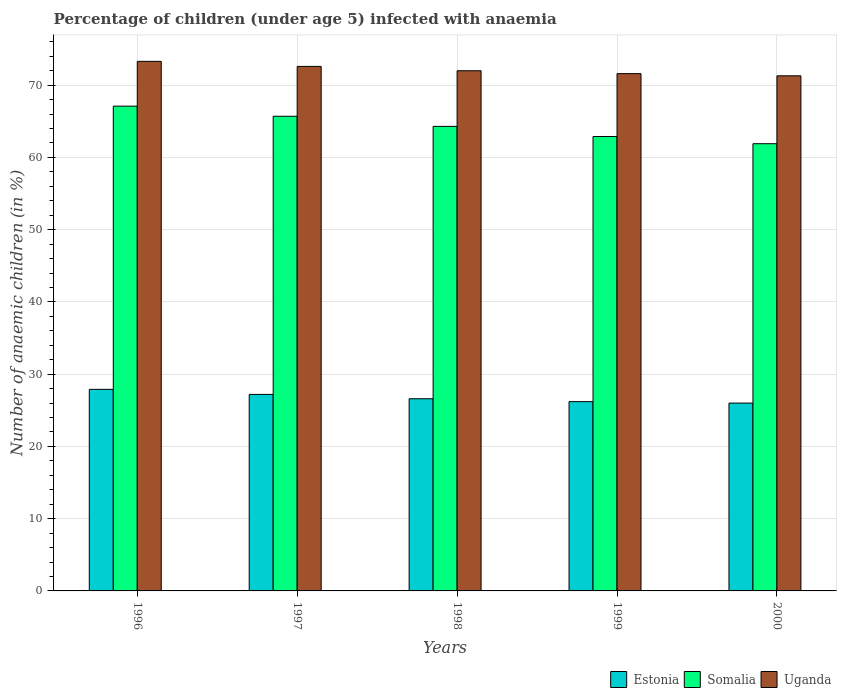How many different coloured bars are there?
Provide a short and direct response. 3. How many groups of bars are there?
Provide a short and direct response. 5. In how many cases, is the number of bars for a given year not equal to the number of legend labels?
Provide a succinct answer. 0. What is the percentage of children infected with anaemia in in Uganda in 1997?
Provide a succinct answer. 72.6. Across all years, what is the maximum percentage of children infected with anaemia in in Estonia?
Your answer should be compact. 27.9. Across all years, what is the minimum percentage of children infected with anaemia in in Uganda?
Provide a short and direct response. 71.3. What is the total percentage of children infected with anaemia in in Uganda in the graph?
Keep it short and to the point. 360.8. What is the difference between the percentage of children infected with anaemia in in Uganda in 1998 and that in 2000?
Give a very brief answer. 0.7. What is the average percentage of children infected with anaemia in in Estonia per year?
Provide a short and direct response. 26.78. In the year 1996, what is the difference between the percentage of children infected with anaemia in in Uganda and percentage of children infected with anaemia in in Estonia?
Keep it short and to the point. 45.4. In how many years, is the percentage of children infected with anaemia in in Estonia greater than 10 %?
Offer a terse response. 5. What is the ratio of the percentage of children infected with anaemia in in Estonia in 1996 to that in 1997?
Ensure brevity in your answer.  1.03. Is the percentage of children infected with anaemia in in Somalia in 1996 less than that in 1997?
Your response must be concise. No. Is the difference between the percentage of children infected with anaemia in in Uganda in 1998 and 2000 greater than the difference between the percentage of children infected with anaemia in in Estonia in 1998 and 2000?
Ensure brevity in your answer.  Yes. What is the difference between the highest and the second highest percentage of children infected with anaemia in in Estonia?
Ensure brevity in your answer.  0.7. What is the difference between the highest and the lowest percentage of children infected with anaemia in in Somalia?
Your answer should be very brief. 5.2. In how many years, is the percentage of children infected with anaemia in in Somalia greater than the average percentage of children infected with anaemia in in Somalia taken over all years?
Offer a very short reply. 2. Is the sum of the percentage of children infected with anaemia in in Estonia in 1998 and 2000 greater than the maximum percentage of children infected with anaemia in in Somalia across all years?
Provide a succinct answer. No. What does the 2nd bar from the left in 1997 represents?
Offer a very short reply. Somalia. What does the 3rd bar from the right in 1997 represents?
Ensure brevity in your answer.  Estonia. How many years are there in the graph?
Your response must be concise. 5. Does the graph contain any zero values?
Make the answer very short. No. How many legend labels are there?
Keep it short and to the point. 3. What is the title of the graph?
Provide a short and direct response. Percentage of children (under age 5) infected with anaemia. Does "World" appear as one of the legend labels in the graph?
Make the answer very short. No. What is the label or title of the Y-axis?
Your answer should be very brief. Number of anaemic children (in %). What is the Number of anaemic children (in %) of Estonia in 1996?
Keep it short and to the point. 27.9. What is the Number of anaemic children (in %) of Somalia in 1996?
Your response must be concise. 67.1. What is the Number of anaemic children (in %) in Uganda in 1996?
Make the answer very short. 73.3. What is the Number of anaemic children (in %) of Estonia in 1997?
Your response must be concise. 27.2. What is the Number of anaemic children (in %) in Somalia in 1997?
Your response must be concise. 65.7. What is the Number of anaemic children (in %) of Uganda in 1997?
Make the answer very short. 72.6. What is the Number of anaemic children (in %) in Estonia in 1998?
Your response must be concise. 26.6. What is the Number of anaemic children (in %) of Somalia in 1998?
Keep it short and to the point. 64.3. What is the Number of anaemic children (in %) in Uganda in 1998?
Keep it short and to the point. 72. What is the Number of anaemic children (in %) of Estonia in 1999?
Provide a short and direct response. 26.2. What is the Number of anaemic children (in %) in Somalia in 1999?
Make the answer very short. 62.9. What is the Number of anaemic children (in %) of Uganda in 1999?
Your answer should be very brief. 71.6. What is the Number of anaemic children (in %) of Estonia in 2000?
Your response must be concise. 26. What is the Number of anaemic children (in %) of Somalia in 2000?
Make the answer very short. 61.9. What is the Number of anaemic children (in %) in Uganda in 2000?
Make the answer very short. 71.3. Across all years, what is the maximum Number of anaemic children (in %) of Estonia?
Your response must be concise. 27.9. Across all years, what is the maximum Number of anaemic children (in %) in Somalia?
Provide a short and direct response. 67.1. Across all years, what is the maximum Number of anaemic children (in %) of Uganda?
Offer a terse response. 73.3. Across all years, what is the minimum Number of anaemic children (in %) of Estonia?
Keep it short and to the point. 26. Across all years, what is the minimum Number of anaemic children (in %) of Somalia?
Your answer should be compact. 61.9. Across all years, what is the minimum Number of anaemic children (in %) in Uganda?
Provide a short and direct response. 71.3. What is the total Number of anaemic children (in %) in Estonia in the graph?
Your answer should be compact. 133.9. What is the total Number of anaemic children (in %) in Somalia in the graph?
Your answer should be very brief. 321.9. What is the total Number of anaemic children (in %) in Uganda in the graph?
Your answer should be very brief. 360.8. What is the difference between the Number of anaemic children (in %) of Uganda in 1996 and that in 1998?
Offer a very short reply. 1.3. What is the difference between the Number of anaemic children (in %) in Estonia in 1996 and that in 2000?
Offer a terse response. 1.9. What is the difference between the Number of anaemic children (in %) in Uganda in 1996 and that in 2000?
Provide a short and direct response. 2. What is the difference between the Number of anaemic children (in %) in Somalia in 1997 and that in 1998?
Keep it short and to the point. 1.4. What is the difference between the Number of anaemic children (in %) of Uganda in 1997 and that in 1998?
Offer a very short reply. 0.6. What is the difference between the Number of anaemic children (in %) of Estonia in 1997 and that in 1999?
Provide a succinct answer. 1. What is the difference between the Number of anaemic children (in %) of Somalia in 1997 and that in 1999?
Your answer should be compact. 2.8. What is the difference between the Number of anaemic children (in %) in Uganda in 1997 and that in 1999?
Provide a short and direct response. 1. What is the difference between the Number of anaemic children (in %) of Estonia in 1997 and that in 2000?
Provide a short and direct response. 1.2. What is the difference between the Number of anaemic children (in %) in Estonia in 1998 and that in 2000?
Offer a terse response. 0.6. What is the difference between the Number of anaemic children (in %) in Uganda in 1998 and that in 2000?
Offer a terse response. 0.7. What is the difference between the Number of anaemic children (in %) in Uganda in 1999 and that in 2000?
Make the answer very short. 0.3. What is the difference between the Number of anaemic children (in %) in Estonia in 1996 and the Number of anaemic children (in %) in Somalia in 1997?
Give a very brief answer. -37.8. What is the difference between the Number of anaemic children (in %) of Estonia in 1996 and the Number of anaemic children (in %) of Uganda in 1997?
Offer a terse response. -44.7. What is the difference between the Number of anaemic children (in %) in Somalia in 1996 and the Number of anaemic children (in %) in Uganda in 1997?
Your answer should be compact. -5.5. What is the difference between the Number of anaemic children (in %) of Estonia in 1996 and the Number of anaemic children (in %) of Somalia in 1998?
Your response must be concise. -36.4. What is the difference between the Number of anaemic children (in %) in Estonia in 1996 and the Number of anaemic children (in %) in Uganda in 1998?
Ensure brevity in your answer.  -44.1. What is the difference between the Number of anaemic children (in %) in Somalia in 1996 and the Number of anaemic children (in %) in Uganda in 1998?
Give a very brief answer. -4.9. What is the difference between the Number of anaemic children (in %) in Estonia in 1996 and the Number of anaemic children (in %) in Somalia in 1999?
Your answer should be compact. -35. What is the difference between the Number of anaemic children (in %) of Estonia in 1996 and the Number of anaemic children (in %) of Uganda in 1999?
Provide a short and direct response. -43.7. What is the difference between the Number of anaemic children (in %) of Somalia in 1996 and the Number of anaemic children (in %) of Uganda in 1999?
Ensure brevity in your answer.  -4.5. What is the difference between the Number of anaemic children (in %) of Estonia in 1996 and the Number of anaemic children (in %) of Somalia in 2000?
Provide a succinct answer. -34. What is the difference between the Number of anaemic children (in %) of Estonia in 1996 and the Number of anaemic children (in %) of Uganda in 2000?
Offer a terse response. -43.4. What is the difference between the Number of anaemic children (in %) of Somalia in 1996 and the Number of anaemic children (in %) of Uganda in 2000?
Your response must be concise. -4.2. What is the difference between the Number of anaemic children (in %) of Estonia in 1997 and the Number of anaemic children (in %) of Somalia in 1998?
Provide a short and direct response. -37.1. What is the difference between the Number of anaemic children (in %) of Estonia in 1997 and the Number of anaemic children (in %) of Uganda in 1998?
Your answer should be very brief. -44.8. What is the difference between the Number of anaemic children (in %) in Estonia in 1997 and the Number of anaemic children (in %) in Somalia in 1999?
Your answer should be very brief. -35.7. What is the difference between the Number of anaemic children (in %) of Estonia in 1997 and the Number of anaemic children (in %) of Uganda in 1999?
Provide a succinct answer. -44.4. What is the difference between the Number of anaemic children (in %) in Estonia in 1997 and the Number of anaemic children (in %) in Somalia in 2000?
Your response must be concise. -34.7. What is the difference between the Number of anaemic children (in %) of Estonia in 1997 and the Number of anaemic children (in %) of Uganda in 2000?
Provide a succinct answer. -44.1. What is the difference between the Number of anaemic children (in %) of Somalia in 1997 and the Number of anaemic children (in %) of Uganda in 2000?
Provide a short and direct response. -5.6. What is the difference between the Number of anaemic children (in %) of Estonia in 1998 and the Number of anaemic children (in %) of Somalia in 1999?
Your answer should be very brief. -36.3. What is the difference between the Number of anaemic children (in %) in Estonia in 1998 and the Number of anaemic children (in %) in Uganda in 1999?
Keep it short and to the point. -45. What is the difference between the Number of anaemic children (in %) of Estonia in 1998 and the Number of anaemic children (in %) of Somalia in 2000?
Provide a succinct answer. -35.3. What is the difference between the Number of anaemic children (in %) of Estonia in 1998 and the Number of anaemic children (in %) of Uganda in 2000?
Provide a succinct answer. -44.7. What is the difference between the Number of anaemic children (in %) of Somalia in 1998 and the Number of anaemic children (in %) of Uganda in 2000?
Provide a succinct answer. -7. What is the difference between the Number of anaemic children (in %) in Estonia in 1999 and the Number of anaemic children (in %) in Somalia in 2000?
Give a very brief answer. -35.7. What is the difference between the Number of anaemic children (in %) in Estonia in 1999 and the Number of anaemic children (in %) in Uganda in 2000?
Your answer should be compact. -45.1. What is the difference between the Number of anaemic children (in %) in Somalia in 1999 and the Number of anaemic children (in %) in Uganda in 2000?
Ensure brevity in your answer.  -8.4. What is the average Number of anaemic children (in %) in Estonia per year?
Your answer should be very brief. 26.78. What is the average Number of anaemic children (in %) in Somalia per year?
Keep it short and to the point. 64.38. What is the average Number of anaemic children (in %) of Uganda per year?
Give a very brief answer. 72.16. In the year 1996, what is the difference between the Number of anaemic children (in %) in Estonia and Number of anaemic children (in %) in Somalia?
Your response must be concise. -39.2. In the year 1996, what is the difference between the Number of anaemic children (in %) of Estonia and Number of anaemic children (in %) of Uganda?
Your answer should be compact. -45.4. In the year 1997, what is the difference between the Number of anaemic children (in %) in Estonia and Number of anaemic children (in %) in Somalia?
Your response must be concise. -38.5. In the year 1997, what is the difference between the Number of anaemic children (in %) of Estonia and Number of anaemic children (in %) of Uganda?
Your response must be concise. -45.4. In the year 1997, what is the difference between the Number of anaemic children (in %) of Somalia and Number of anaemic children (in %) of Uganda?
Your answer should be very brief. -6.9. In the year 1998, what is the difference between the Number of anaemic children (in %) in Estonia and Number of anaemic children (in %) in Somalia?
Offer a terse response. -37.7. In the year 1998, what is the difference between the Number of anaemic children (in %) in Estonia and Number of anaemic children (in %) in Uganda?
Offer a terse response. -45.4. In the year 1999, what is the difference between the Number of anaemic children (in %) of Estonia and Number of anaemic children (in %) of Somalia?
Offer a very short reply. -36.7. In the year 1999, what is the difference between the Number of anaemic children (in %) in Estonia and Number of anaemic children (in %) in Uganda?
Your response must be concise. -45.4. In the year 2000, what is the difference between the Number of anaemic children (in %) in Estonia and Number of anaemic children (in %) in Somalia?
Give a very brief answer. -35.9. In the year 2000, what is the difference between the Number of anaemic children (in %) of Estonia and Number of anaemic children (in %) of Uganda?
Your answer should be very brief. -45.3. In the year 2000, what is the difference between the Number of anaemic children (in %) in Somalia and Number of anaemic children (in %) in Uganda?
Your answer should be very brief. -9.4. What is the ratio of the Number of anaemic children (in %) in Estonia in 1996 to that in 1997?
Your response must be concise. 1.03. What is the ratio of the Number of anaemic children (in %) in Somalia in 1996 to that in 1997?
Offer a terse response. 1.02. What is the ratio of the Number of anaemic children (in %) of Uganda in 1996 to that in 1997?
Your answer should be very brief. 1.01. What is the ratio of the Number of anaemic children (in %) of Estonia in 1996 to that in 1998?
Your answer should be very brief. 1.05. What is the ratio of the Number of anaemic children (in %) of Somalia in 1996 to that in 1998?
Provide a short and direct response. 1.04. What is the ratio of the Number of anaemic children (in %) in Uganda in 1996 to that in 1998?
Your answer should be very brief. 1.02. What is the ratio of the Number of anaemic children (in %) in Estonia in 1996 to that in 1999?
Make the answer very short. 1.06. What is the ratio of the Number of anaemic children (in %) in Somalia in 1996 to that in 1999?
Your response must be concise. 1.07. What is the ratio of the Number of anaemic children (in %) in Uganda in 1996 to that in 1999?
Provide a succinct answer. 1.02. What is the ratio of the Number of anaemic children (in %) of Estonia in 1996 to that in 2000?
Your answer should be compact. 1.07. What is the ratio of the Number of anaemic children (in %) in Somalia in 1996 to that in 2000?
Ensure brevity in your answer.  1.08. What is the ratio of the Number of anaemic children (in %) in Uganda in 1996 to that in 2000?
Ensure brevity in your answer.  1.03. What is the ratio of the Number of anaemic children (in %) of Estonia in 1997 to that in 1998?
Ensure brevity in your answer.  1.02. What is the ratio of the Number of anaemic children (in %) in Somalia in 1997 to that in 1998?
Keep it short and to the point. 1.02. What is the ratio of the Number of anaemic children (in %) of Uganda in 1997 to that in 1998?
Ensure brevity in your answer.  1.01. What is the ratio of the Number of anaemic children (in %) of Estonia in 1997 to that in 1999?
Offer a very short reply. 1.04. What is the ratio of the Number of anaemic children (in %) in Somalia in 1997 to that in 1999?
Provide a succinct answer. 1.04. What is the ratio of the Number of anaemic children (in %) in Estonia in 1997 to that in 2000?
Provide a succinct answer. 1.05. What is the ratio of the Number of anaemic children (in %) of Somalia in 1997 to that in 2000?
Keep it short and to the point. 1.06. What is the ratio of the Number of anaemic children (in %) of Uganda in 1997 to that in 2000?
Keep it short and to the point. 1.02. What is the ratio of the Number of anaemic children (in %) in Estonia in 1998 to that in 1999?
Ensure brevity in your answer.  1.02. What is the ratio of the Number of anaemic children (in %) of Somalia in 1998 to that in 1999?
Offer a terse response. 1.02. What is the ratio of the Number of anaemic children (in %) in Uganda in 1998 to that in 1999?
Make the answer very short. 1.01. What is the ratio of the Number of anaemic children (in %) of Estonia in 1998 to that in 2000?
Provide a short and direct response. 1.02. What is the ratio of the Number of anaemic children (in %) of Somalia in 1998 to that in 2000?
Provide a short and direct response. 1.04. What is the ratio of the Number of anaemic children (in %) in Uganda in 1998 to that in 2000?
Make the answer very short. 1.01. What is the ratio of the Number of anaemic children (in %) in Estonia in 1999 to that in 2000?
Your response must be concise. 1.01. What is the ratio of the Number of anaemic children (in %) of Somalia in 1999 to that in 2000?
Offer a very short reply. 1.02. What is the ratio of the Number of anaemic children (in %) in Uganda in 1999 to that in 2000?
Keep it short and to the point. 1. What is the difference between the highest and the second highest Number of anaemic children (in %) in Somalia?
Provide a succinct answer. 1.4. What is the difference between the highest and the second highest Number of anaemic children (in %) in Uganda?
Make the answer very short. 0.7. What is the difference between the highest and the lowest Number of anaemic children (in %) in Estonia?
Provide a succinct answer. 1.9. 